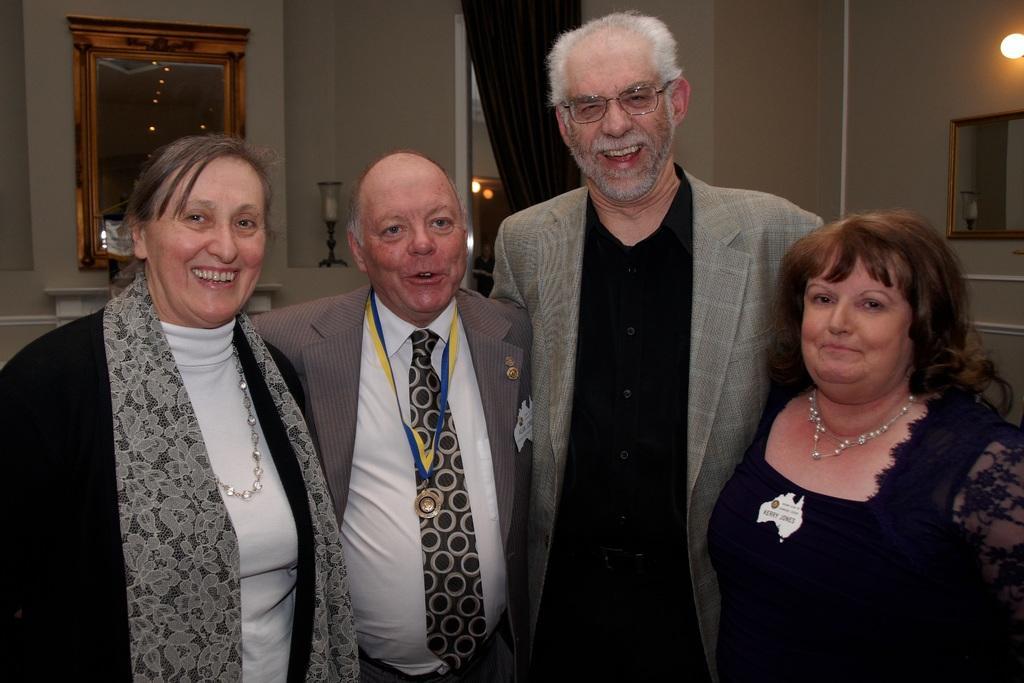In one or two sentences, can you explain what this image depicts? In this image I can see group of people stand, in front the person is wearing gray blazer, black shirt and the person at left wearing gray blazer, white shirt and black color tie. Background I can see a mirror attached to the wall and the wall is in gray color, I can also see a black color curtain. 